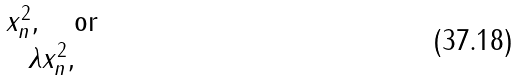Convert formula to latex. <formula><loc_0><loc_0><loc_500><loc_500>\begin{matrix} x _ { n } ^ { 2 } , \quad \text {or} \\ \lambda x _ { n } ^ { 2 } , \end{matrix}</formula> 